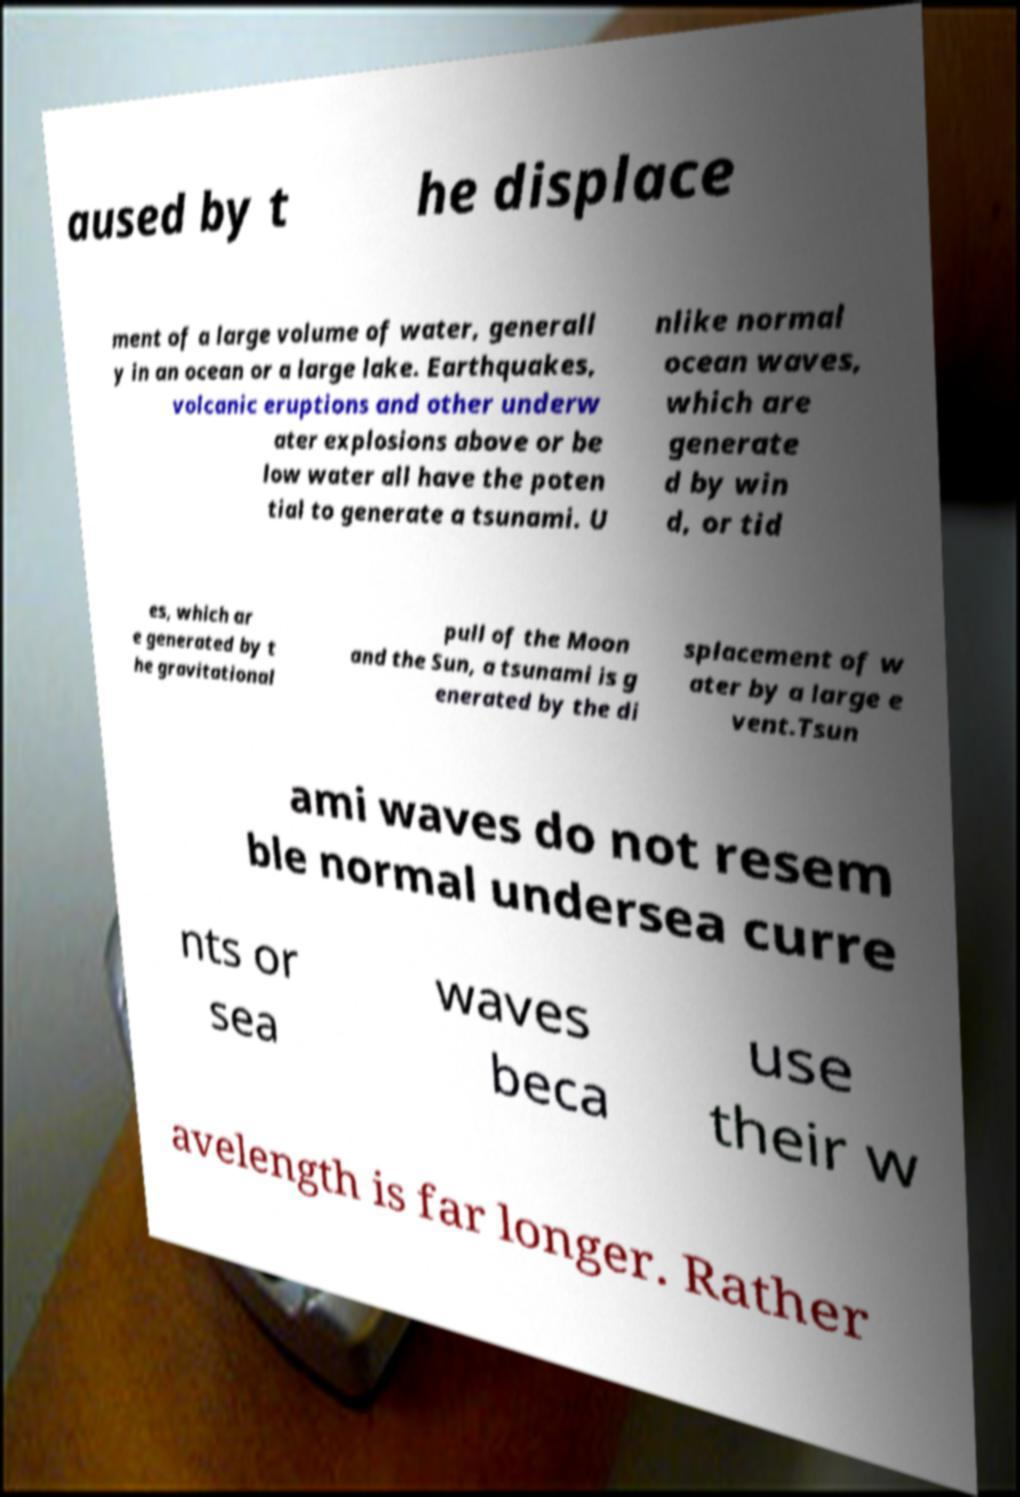There's text embedded in this image that I need extracted. Can you transcribe it verbatim? aused by t he displace ment of a large volume of water, generall y in an ocean or a large lake. Earthquakes, volcanic eruptions and other underw ater explosions above or be low water all have the poten tial to generate a tsunami. U nlike normal ocean waves, which are generate d by win d, or tid es, which ar e generated by t he gravitational pull of the Moon and the Sun, a tsunami is g enerated by the di splacement of w ater by a large e vent.Tsun ami waves do not resem ble normal undersea curre nts or sea waves beca use their w avelength is far longer. Rather 